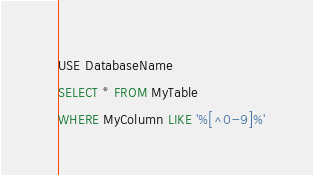<code> <loc_0><loc_0><loc_500><loc_500><_SQL_>
USE DatabaseName
SELECT * FROM MyTable
WHERE MyColumn LIKE '%[^0-9]%'
</code> 